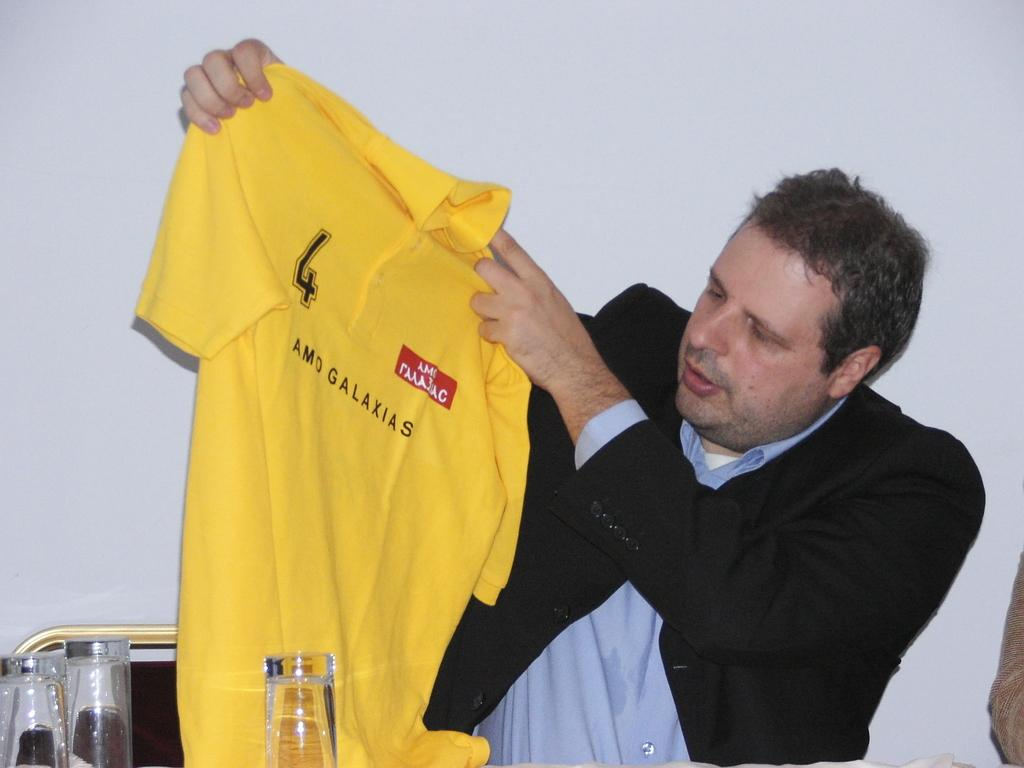<image>
Relay a brief, clear account of the picture shown. A man wearing a suit is holding up a yellow AMO Galaxias jersey. 